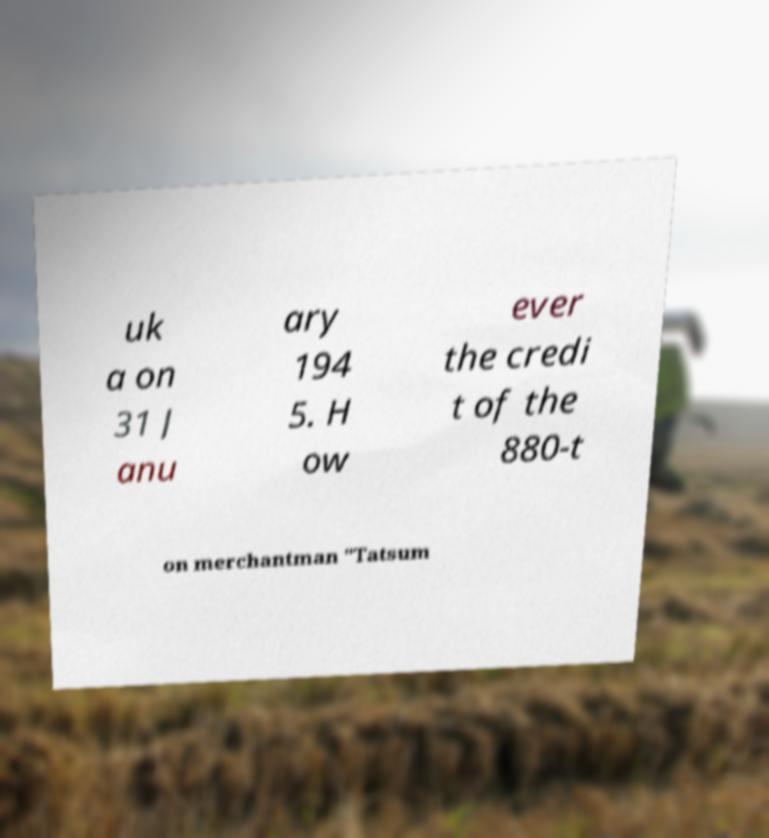Can you accurately transcribe the text from the provided image for me? uk a on 31 J anu ary 194 5. H ow ever the credi t of the 880-t on merchantman "Tatsum 